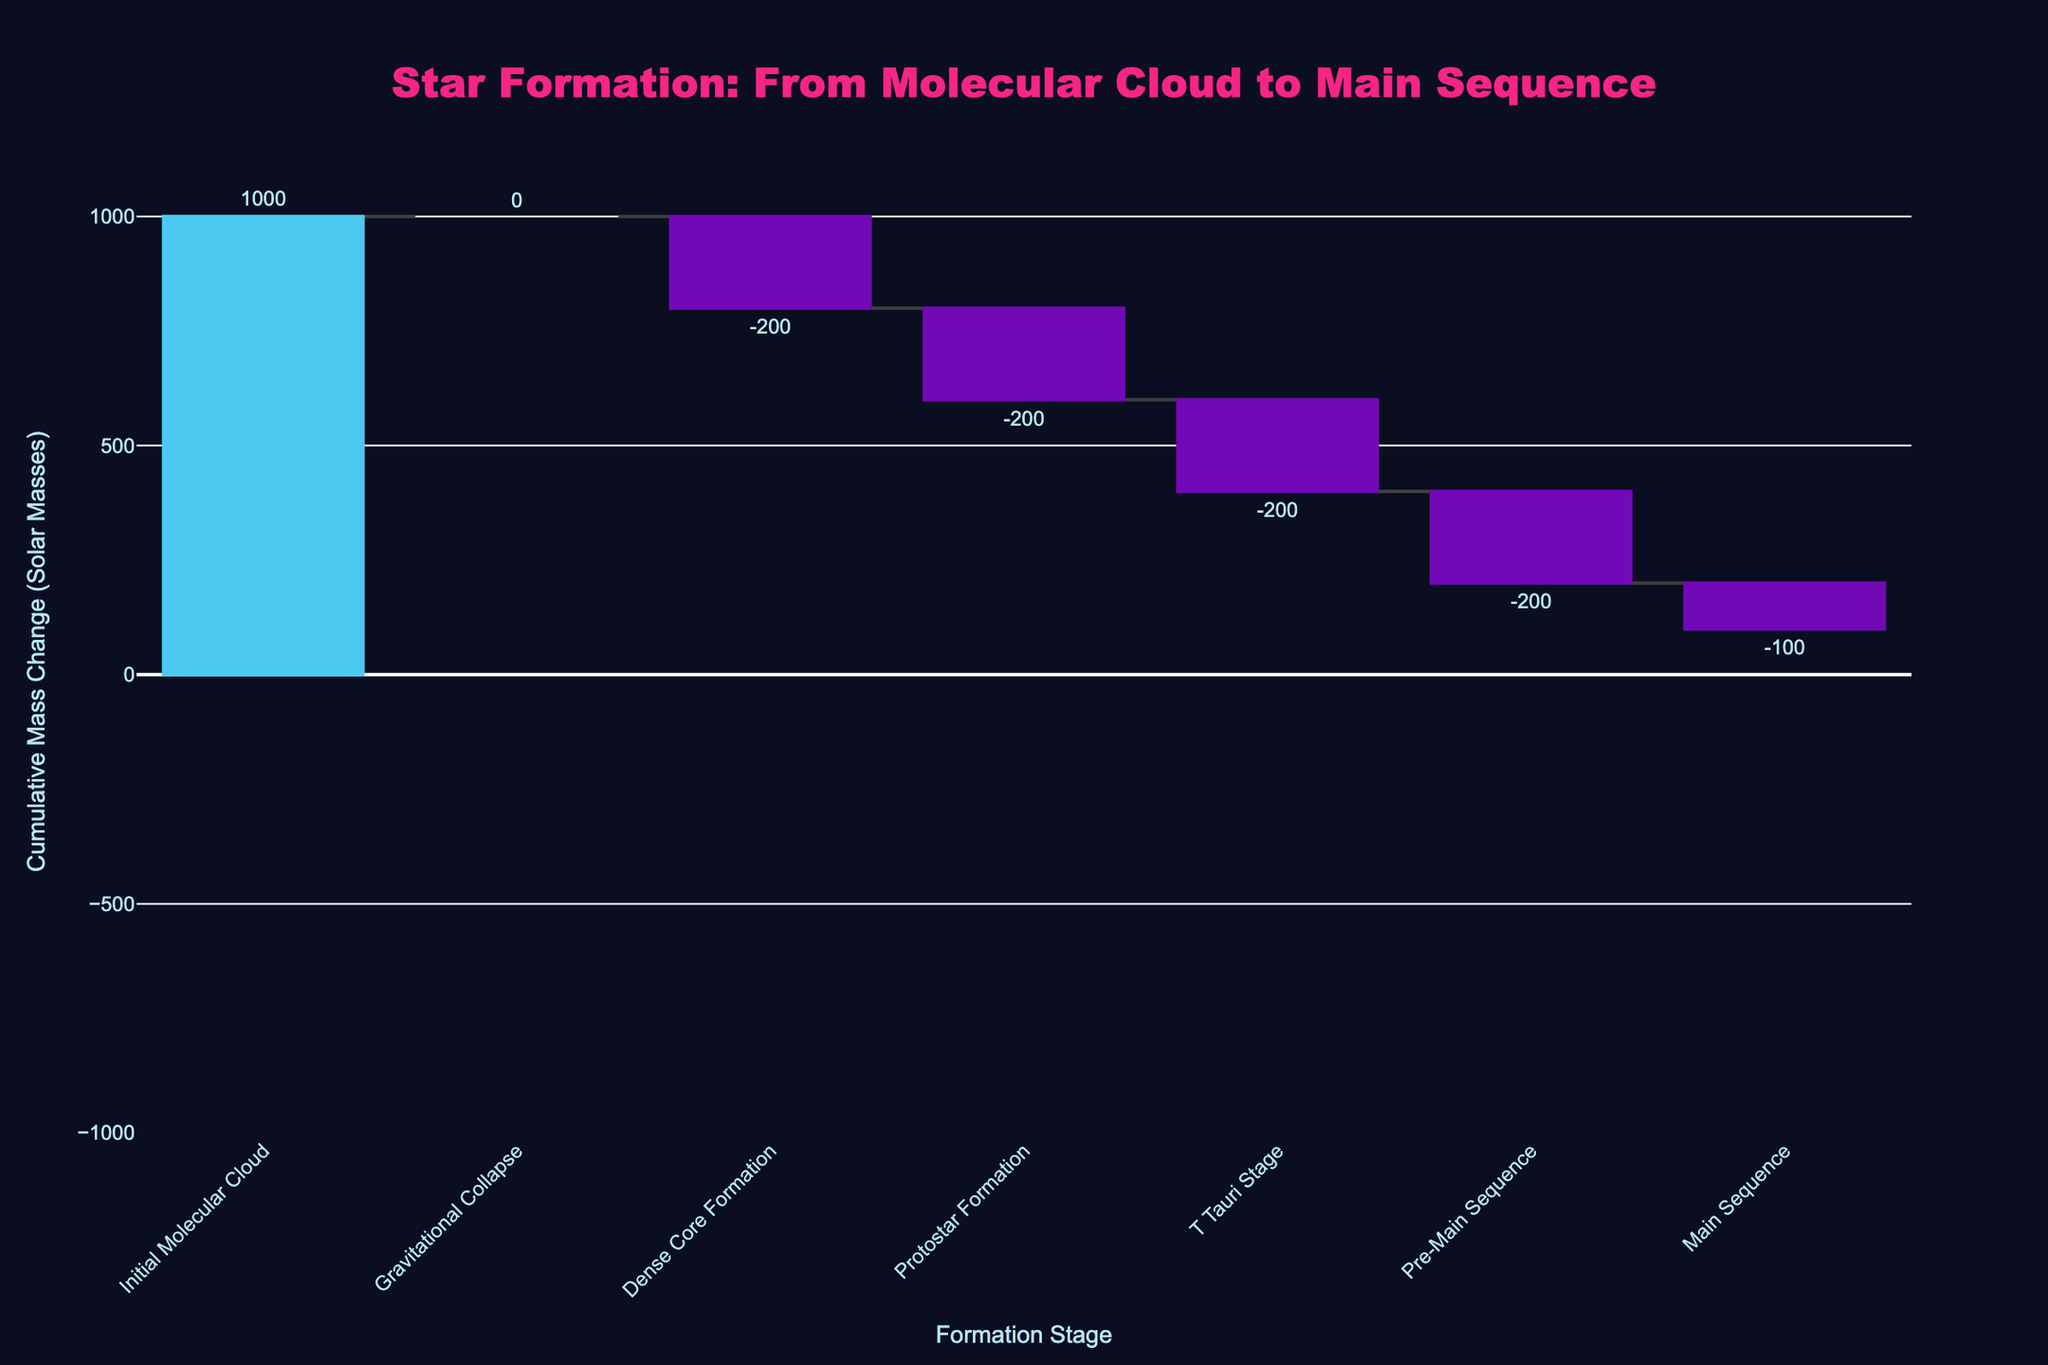What is the title of the chart? The title is typically placed at the top of the chart and is used to describe what the chart represents. Here, it informs us about the star formation process.
Answer: Star Formation: From Molecular Cloud to Main Sequence What is the y-axis title? The y-axis title is usually found along the vertical axis, indicating what the values on this axis represent.
Answer: Cumulative Mass Change (Solar Masses) What stage comes immediately after the Gravitational Collapse in the star formation process? By following the stages in sequence from left to right, you can identify which stage follows another.
Answer: Dense Core Formation How much mass is lost during the Protostar Formation stage? Check the bar for the Protostar Formation stage to see the change in mass from the previous stage. The text on the bar shows this change.
Answer: 200 Solar Masses What is the total cumulative mass at the Main Sequence stage? The cumulative mass at each stage is shown on top of each bar in the waterfall chart. For the Main Sequence stage, this value is given directly.
Answer: 100 Solar Masses Which stage shows the largest decrease in mass? To identify the largest decrease, compare the lengths of the downward bars. The longest downward bar represents the largest mass loss.
Answer: Pre-Main Sequence What is the average cumulative mass change between all stages except the Main Sequence? Add the cumulative mass changes for each stage except the Main Sequence and divide by the number of those stages. (1000 + (-200) + (-200) + (-200) + (-200)) / 5 = 200
Answer: 200 Solar Masses How does the mass change between Dense Core Formation and Pre-Main Sequence compare to the Initial Molecular Cloud and Main Sequence change? Compare the cumulative mass changes between the two specified sequences by calculating the differences: (-800 from Dense Core to Pre-Main Sequence) versus (-900 from Initial Molecular Cloud to Main Sequence).
Answer: Dense Core to Pre-Main Sequence shows a smaller change What mass change occurs during the T Tauri stage, and how long does it last? Check the bar labeled T Tauri Stage for mass change and read off the text to get the time duration from the hover/template data.
Answer: -200 Solar Masses, 1,000,000 Years Which stages show increasing cumulative mass, and how much increase is there at each of those stages? Identify the bars with a positive direction from the previous stage, labeled by different color coding for increasing values.
Answer: Initial Molecular Cloud, 1000 Solar Masses 